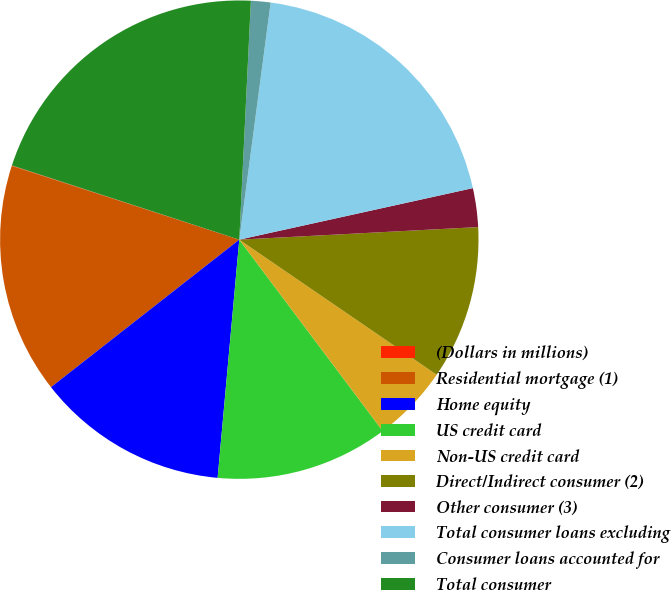Convert chart. <chart><loc_0><loc_0><loc_500><loc_500><pie_chart><fcel>(Dollars in millions)<fcel>Residential mortgage (1)<fcel>Home equity<fcel>US credit card<fcel>Non-US credit card<fcel>Direct/Indirect consumer (2)<fcel>Other consumer (3)<fcel>Total consumer loans excluding<fcel>Consumer loans accounted for<fcel>Total consumer<nl><fcel>0.03%<fcel>15.57%<fcel>12.98%<fcel>11.68%<fcel>5.21%<fcel>10.39%<fcel>2.62%<fcel>19.45%<fcel>1.32%<fcel>20.75%<nl></chart> 